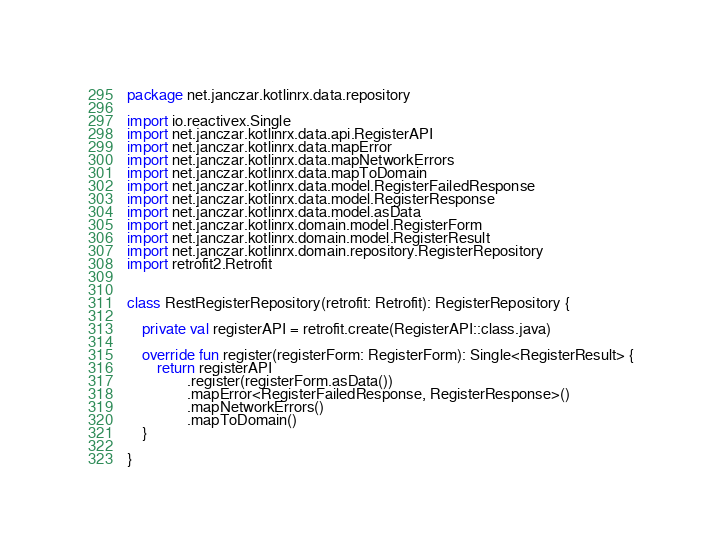Convert code to text. <code><loc_0><loc_0><loc_500><loc_500><_Kotlin_>package net.janczar.kotlinrx.data.repository

import io.reactivex.Single
import net.janczar.kotlinrx.data.api.RegisterAPI
import net.janczar.kotlinrx.data.mapError
import net.janczar.kotlinrx.data.mapNetworkErrors
import net.janczar.kotlinrx.data.mapToDomain
import net.janczar.kotlinrx.data.model.RegisterFailedResponse
import net.janczar.kotlinrx.data.model.RegisterResponse
import net.janczar.kotlinrx.data.model.asData
import net.janczar.kotlinrx.domain.model.RegisterForm
import net.janczar.kotlinrx.domain.model.RegisterResult
import net.janczar.kotlinrx.domain.repository.RegisterRepository
import retrofit2.Retrofit


class RestRegisterRepository(retrofit: Retrofit): RegisterRepository {

    private val registerAPI = retrofit.create(RegisterAPI::class.java)

    override fun register(registerForm: RegisterForm): Single<RegisterResult> {
        return registerAPI
                .register(registerForm.asData())
                .mapError<RegisterFailedResponse, RegisterResponse>()
                .mapNetworkErrors()
                .mapToDomain()
    }

}</code> 